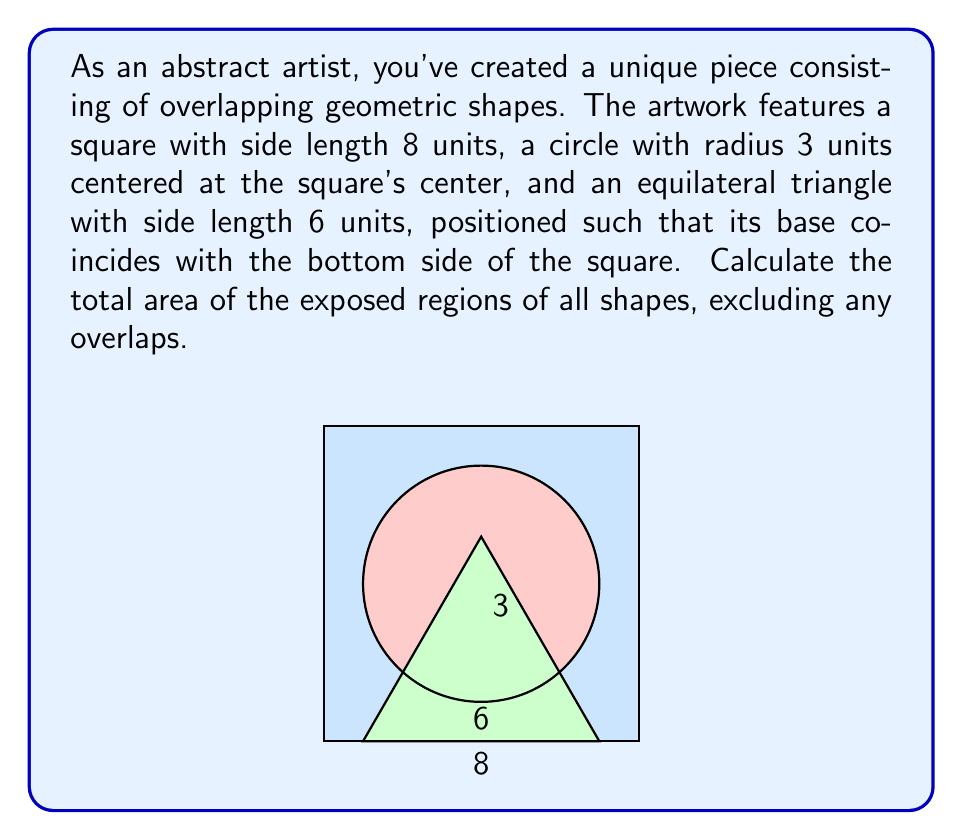What is the answer to this math problem? Let's break this problem down into steps:

1) First, we need to calculate the areas of each shape individually:

   a) Area of the square: $A_s = s^2 = 8^2 = 64$ square units

   b) Area of the circle: $A_c = \pi r^2 = \pi \cdot 3^2 = 9\pi$ square units

   c) Area of the equilateral triangle:
      Height of the triangle: $h = \frac{\sqrt{3}}{2} \cdot 6 = 3\sqrt{3}$
      Area: $A_t = \frac{1}{2} \cdot 6 \cdot 3\sqrt{3} = 9\sqrt{3}$ square units

2) Now, we need to subtract the overlapping areas:

   a) The circle is entirely within the square, so we don't need to subtract anything here.

   b) The overlap between the triangle and the square is just the entire triangle, so we don't need to calculate this separately.

   c) The overlap between the circle and the triangle:
      This is a circular segment. The area of a circular segment is given by:
      $A_{segment} = r^2 \arccos(\frac{r-h}{r}) - (r-h)\sqrt{2rh-h^2}$

      Where $r$ is the radius of the circle (3) and $h$ is the height of the segment.

      To find $h$, we need to calculate the distance from the center of the circle to the base of the triangle:
      $h = 4 - \frac{3\sqrt{3}}{2} = 4 - \frac{3\sqrt{3}}{2} \approx 1.402$

      Plugging this into our formula:
      $A_{segment} = 3^2 \arccos(\frac{3-1.402}{3}) - (3-1.402)\sqrt{2\cdot3\cdot1.402-1.402^2}$
      $\approx 3.648$ square units

3) The total exposed area is therefore:
   $A_{total} = A_s + A_c + A_t - A_{segment}$
   $= 64 + 9\pi + 9\sqrt{3} - 3.648$
   $\approx 64 + 28.274 + 15.588 - 3.648$
   $\approx 104.214$ square units
Answer: $64 + 9\pi + 9\sqrt{3} - 3.648 \approx 104.214$ square units 